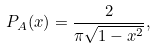<formula> <loc_0><loc_0><loc_500><loc_500>P _ { A } ( x ) = \frac { 2 } { \pi \sqrt { 1 - x ^ { 2 } } } ,</formula> 